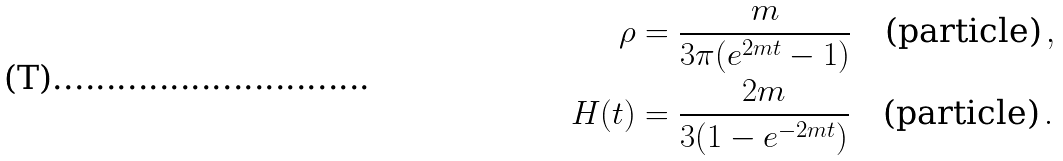Convert formula to latex. <formula><loc_0><loc_0><loc_500><loc_500>\rho & = \frac { m } { 3 \pi ( e ^ { 2 m t } - 1 ) } \quad \text {(particle)} \, , \\ H ( t ) & = \frac { 2 m } { 3 ( 1 - e ^ { - 2 m t } ) } \quad \text {(particle)} \, .</formula> 